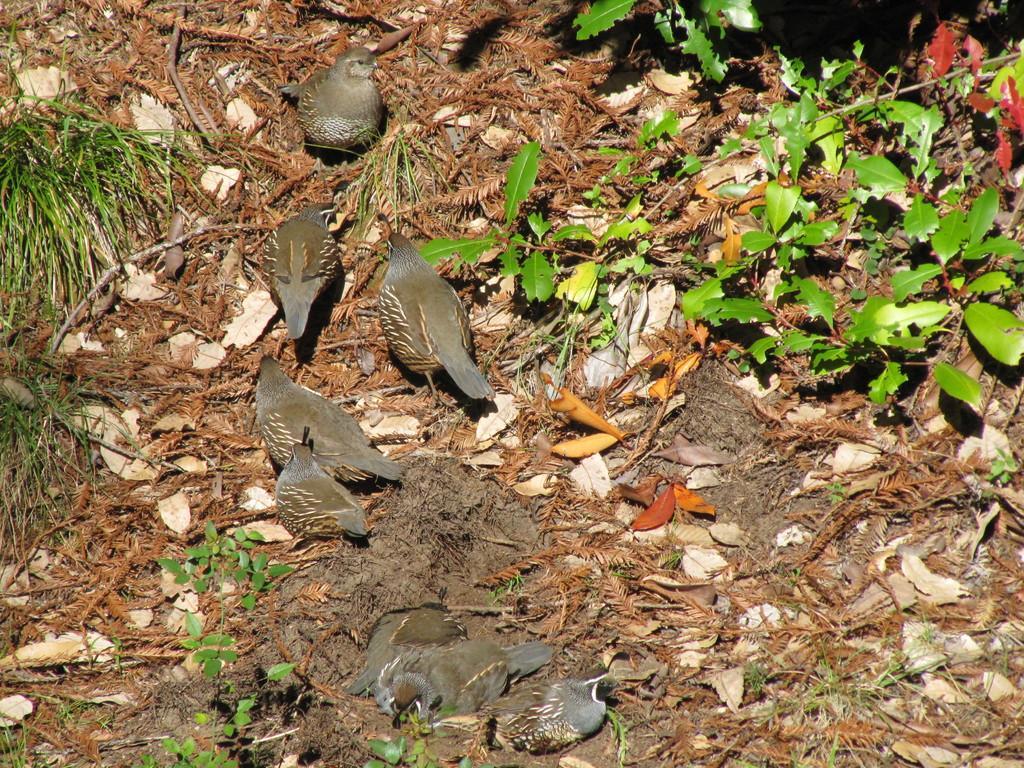Please provide a concise description of this image. In this image in the center there are birds and on the ground there are dry leaves and there are plants. 